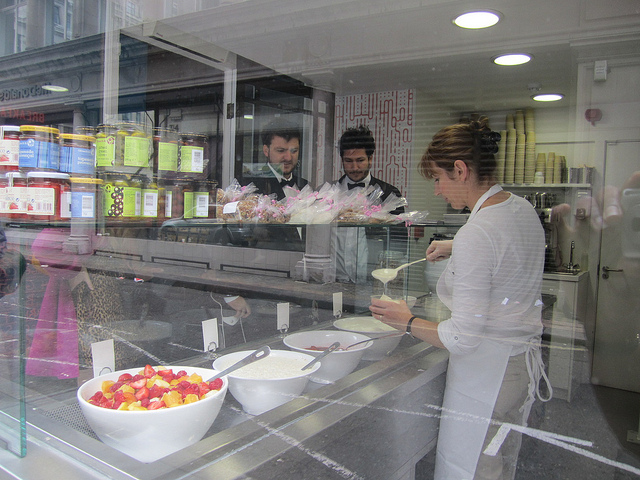What kind of store is depicted in the image? The image shows a food-related store, likely a deli or small grocery shop, given the glass display of food items and the shelves stocked with various products in the background. 